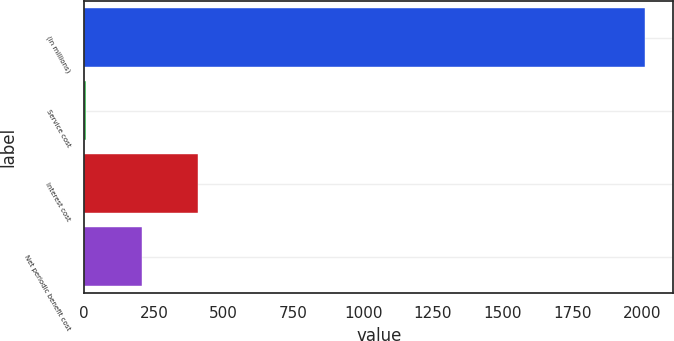<chart> <loc_0><loc_0><loc_500><loc_500><bar_chart><fcel>(in millions)<fcel>Service cost<fcel>Interest cost<fcel>Net periodic benefit cost<nl><fcel>2012<fcel>5<fcel>406.4<fcel>205.7<nl></chart> 